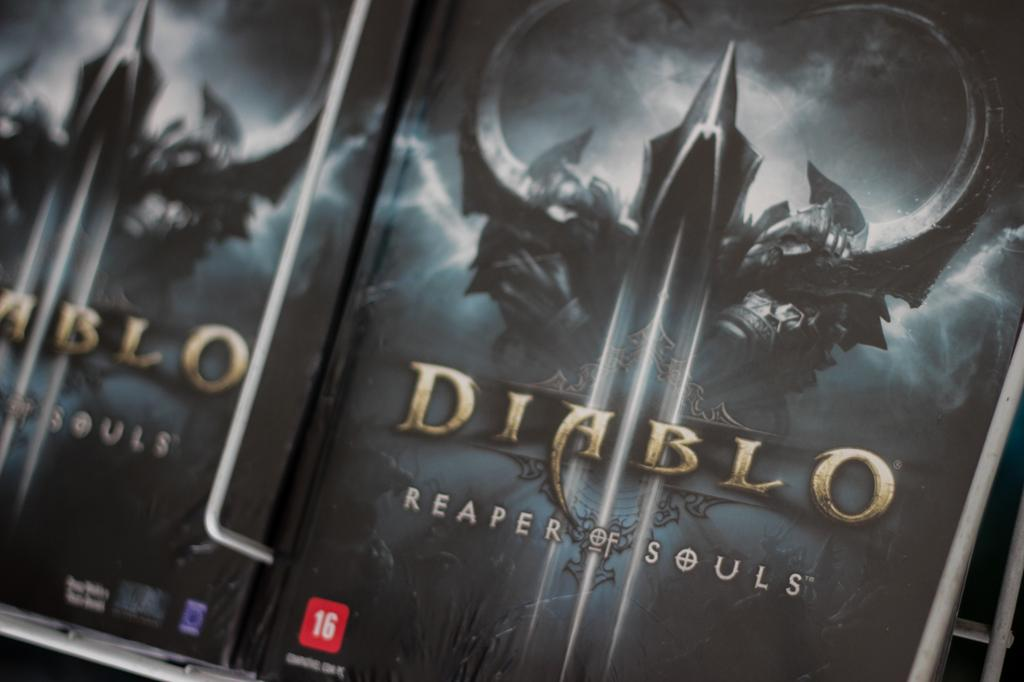<image>
Render a clear and concise summary of the photo. Several copies of Diablo Reaper of Souls the video game on display. 